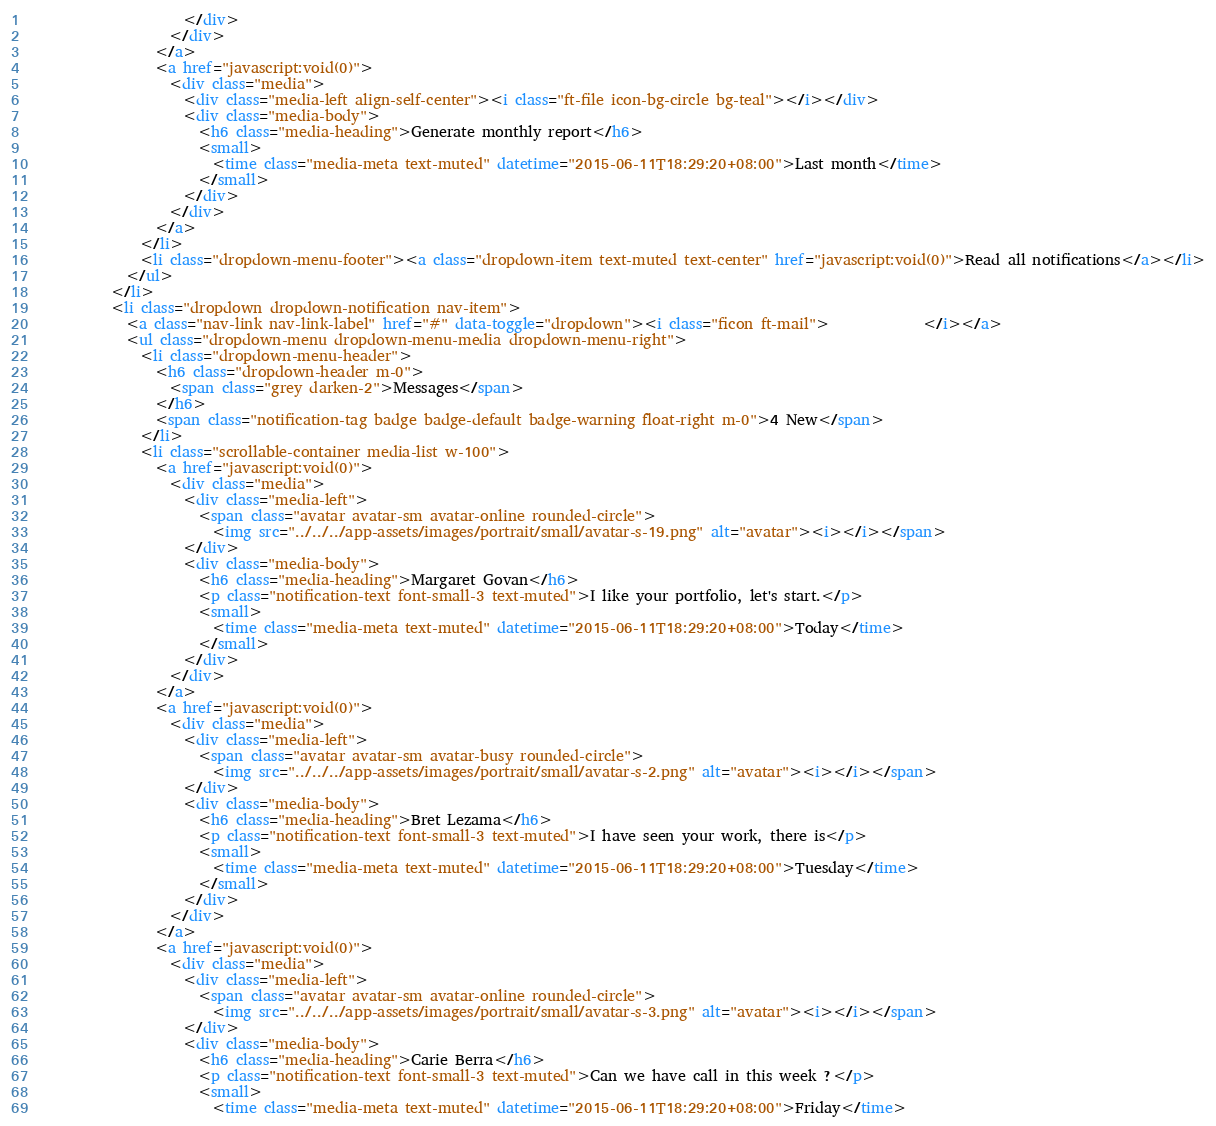Convert code to text. <code><loc_0><loc_0><loc_500><loc_500><_HTML_>                      </div>
                    </div>
                  </a>
                  <a href="javascript:void(0)">
                    <div class="media">
                      <div class="media-left align-self-center"><i class="ft-file icon-bg-circle bg-teal"></i></div>
                      <div class="media-body">
                        <h6 class="media-heading">Generate monthly report</h6>
                        <small>
                          <time class="media-meta text-muted" datetime="2015-06-11T18:29:20+08:00">Last month</time>
                        </small>
                      </div>
                    </div>
                  </a>
                </li>
                <li class="dropdown-menu-footer"><a class="dropdown-item text-muted text-center" href="javascript:void(0)">Read all notifications</a></li>
              </ul>
            </li>
            <li class="dropdown dropdown-notification nav-item">
              <a class="nav-link nav-link-label" href="#" data-toggle="dropdown"><i class="ficon ft-mail">             </i></a>
              <ul class="dropdown-menu dropdown-menu-media dropdown-menu-right">
                <li class="dropdown-menu-header">
                  <h6 class="dropdown-header m-0">
                    <span class="grey darken-2">Messages</span>
                  </h6>
                  <span class="notification-tag badge badge-default badge-warning float-right m-0">4 New</span>
                </li>
                <li class="scrollable-container media-list w-100">
                  <a href="javascript:void(0)">
                    <div class="media">
                      <div class="media-left">
                        <span class="avatar avatar-sm avatar-online rounded-circle">
                          <img src="../../../app-assets/images/portrait/small/avatar-s-19.png" alt="avatar"><i></i></span>
                      </div>
                      <div class="media-body">
                        <h6 class="media-heading">Margaret Govan</h6>
                        <p class="notification-text font-small-3 text-muted">I like your portfolio, let's start.</p>
                        <small>
                          <time class="media-meta text-muted" datetime="2015-06-11T18:29:20+08:00">Today</time>
                        </small>
                      </div>
                    </div>
                  </a>
                  <a href="javascript:void(0)">
                    <div class="media">
                      <div class="media-left">
                        <span class="avatar avatar-sm avatar-busy rounded-circle">
                          <img src="../../../app-assets/images/portrait/small/avatar-s-2.png" alt="avatar"><i></i></span>
                      </div>
                      <div class="media-body">
                        <h6 class="media-heading">Bret Lezama</h6>
                        <p class="notification-text font-small-3 text-muted">I have seen your work, there is</p>
                        <small>
                          <time class="media-meta text-muted" datetime="2015-06-11T18:29:20+08:00">Tuesday</time>
                        </small>
                      </div>
                    </div>
                  </a>
                  <a href="javascript:void(0)">
                    <div class="media">
                      <div class="media-left">
                        <span class="avatar avatar-sm avatar-online rounded-circle">
                          <img src="../../../app-assets/images/portrait/small/avatar-s-3.png" alt="avatar"><i></i></span>
                      </div>
                      <div class="media-body">
                        <h6 class="media-heading">Carie Berra</h6>
                        <p class="notification-text font-small-3 text-muted">Can we have call in this week ?</p>
                        <small>
                          <time class="media-meta text-muted" datetime="2015-06-11T18:29:20+08:00">Friday</time></code> 